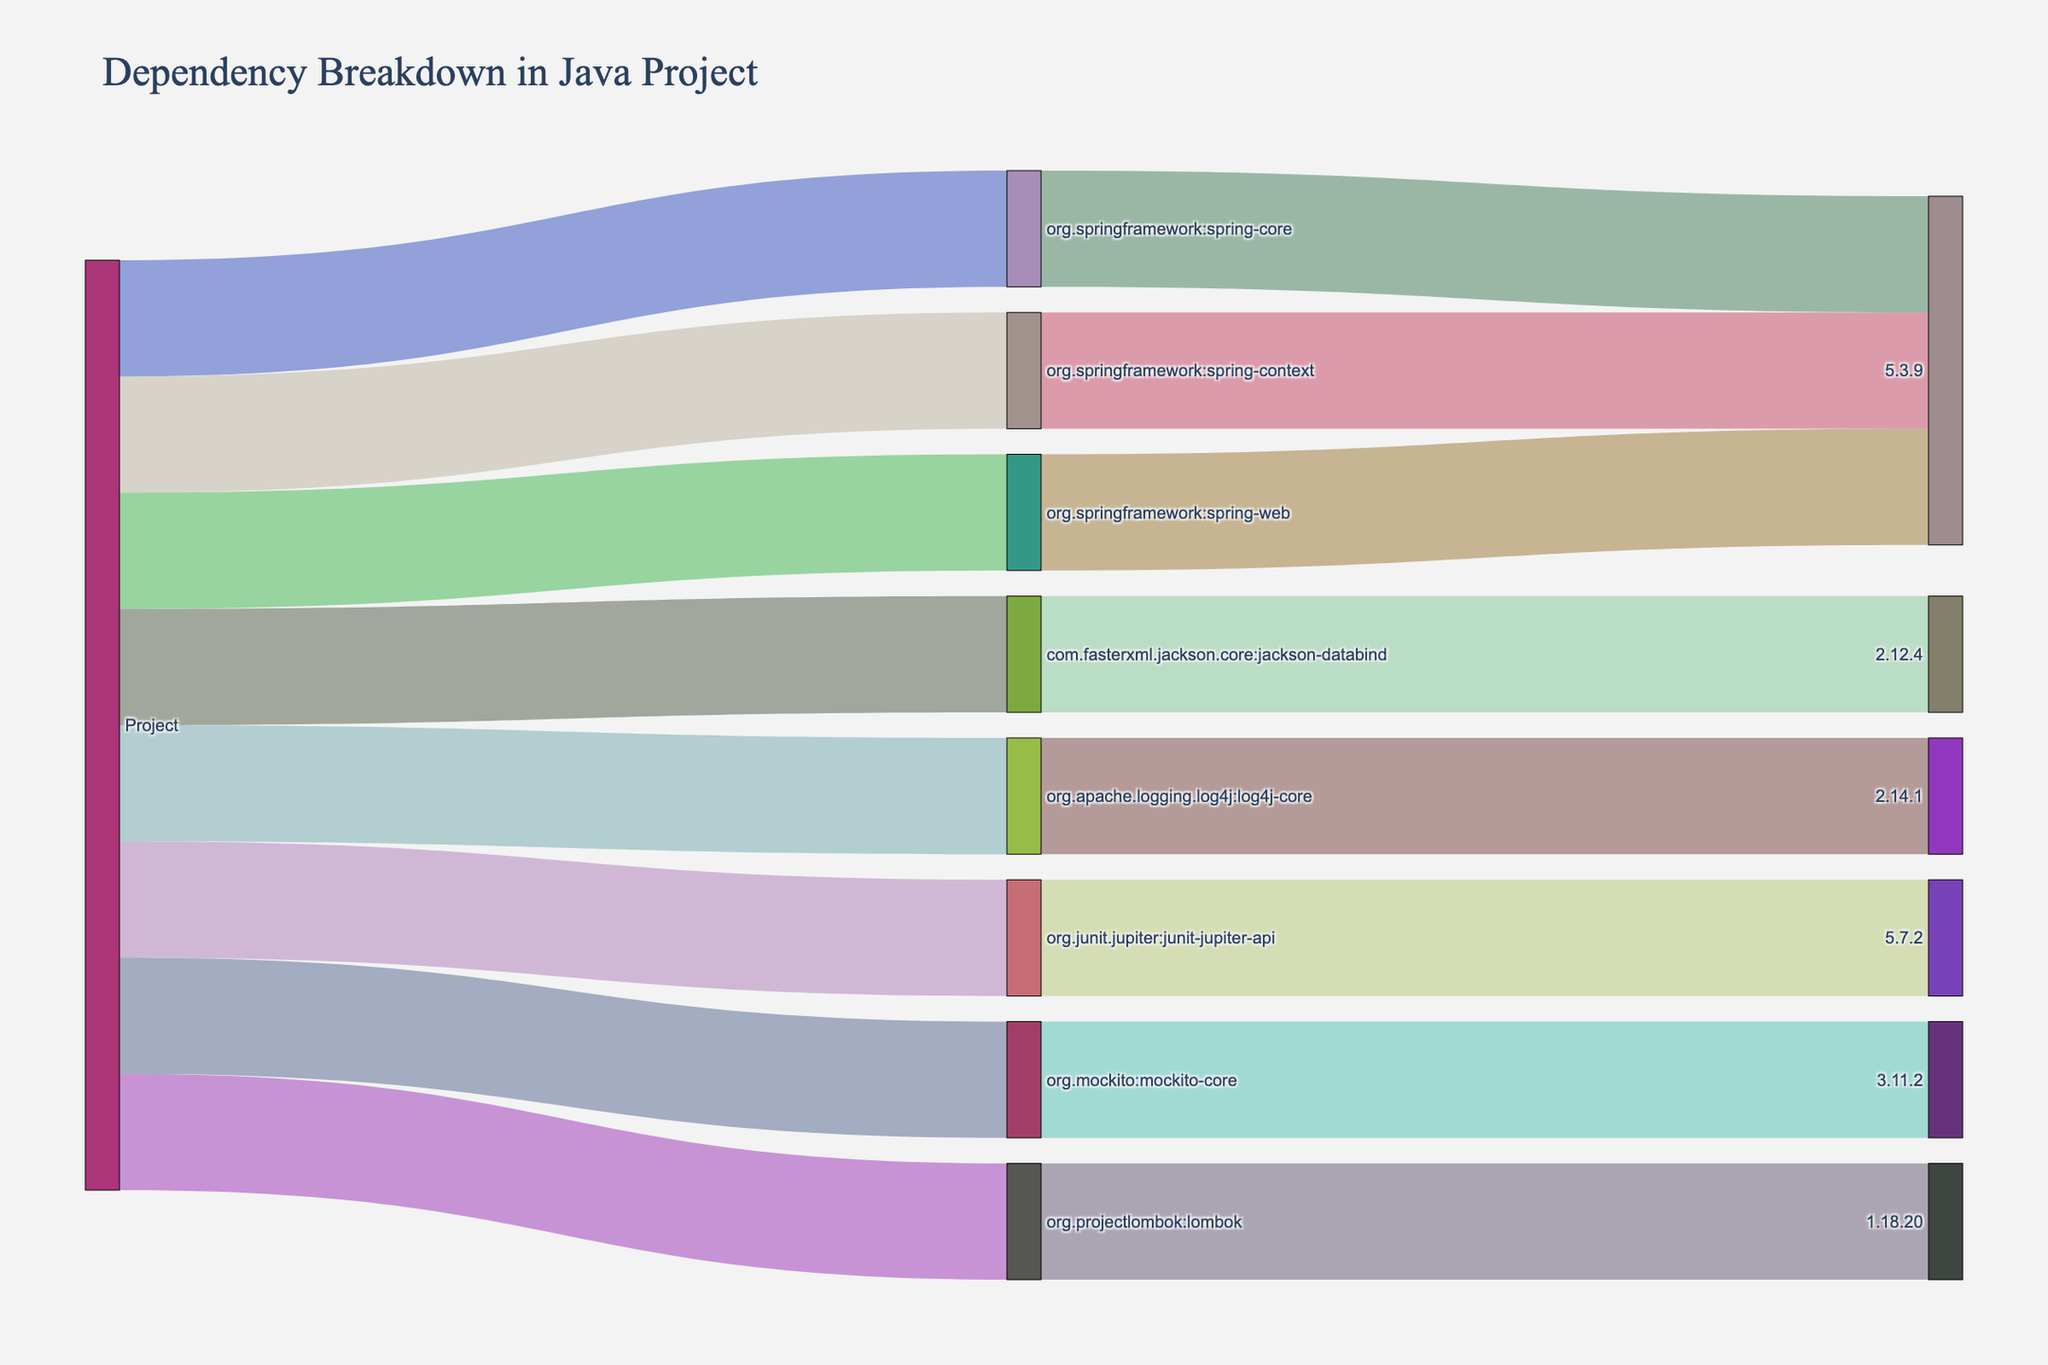How many dependencies are included in the project? Refer to the figure and count the number of direct dependencies connected to the "Project" node.
Answer: 8 What is the most common version used for the Spring framework dependencies? Identify the versions connected to Spring-related nodes (spring-core, spring-context, spring-web) and note the most frequent version.
Answer: 5.3.9 Which dependency has the highest version number? Look at the versions connected to each dependency and identify the highest numerical value.
Answer: lombok (1.18.20) Which dependency connected to the project has the highest version among all dependencies? Compare all version numbers connected to each dependency. Find and specify the highest version number.
Answer: lombok, 1.18.20 Are there any dependencies in the figure that are not related to testing? Identify the dependencies and their purposes; determine if there are any non-testing dependencies.
Answer: Yes, there are five: org.springframework:spring-core, org.springframework:spring-context, org.springframework:spring-web, com.fasterxml.jackson.core:jackson-databind, org.apache.logging.log4j:log4j-core Which dependencies are specifically used for testing purposes in the figure? Identify dependencies commonly used for testing (e.g., JUnit, Mockito) and confirm their presence in the figure.
Answer: org.junit.jupiter:junit-jupiter-api, org.mockito:mockito-core What version of jackson-databind is used in the project? Look at the connection from com.fasterxml.jackson.core:jackson-databind to its version and note the version number.
Answer: 2.12.4 How many Spring-related dependencies are present in the diagram? Count the number of dependencies related specifically to the Spring framework.
Answer: 3 Which dependency in the project has the version 5.7.2? Trace the node with the version 5.7.2 back to its dependency node.
Answer: org.junit.jupiter:junit-jupiter-api 